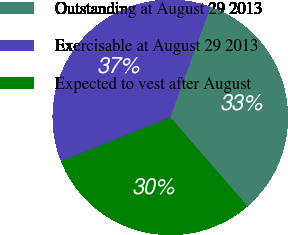<chart> <loc_0><loc_0><loc_500><loc_500><pie_chart><fcel>Outstanding at August 29 2013<fcel>Exercisable at August 29 2013<fcel>Expected to vest after August<nl><fcel>33.08%<fcel>36.65%<fcel>30.27%<nl></chart> 